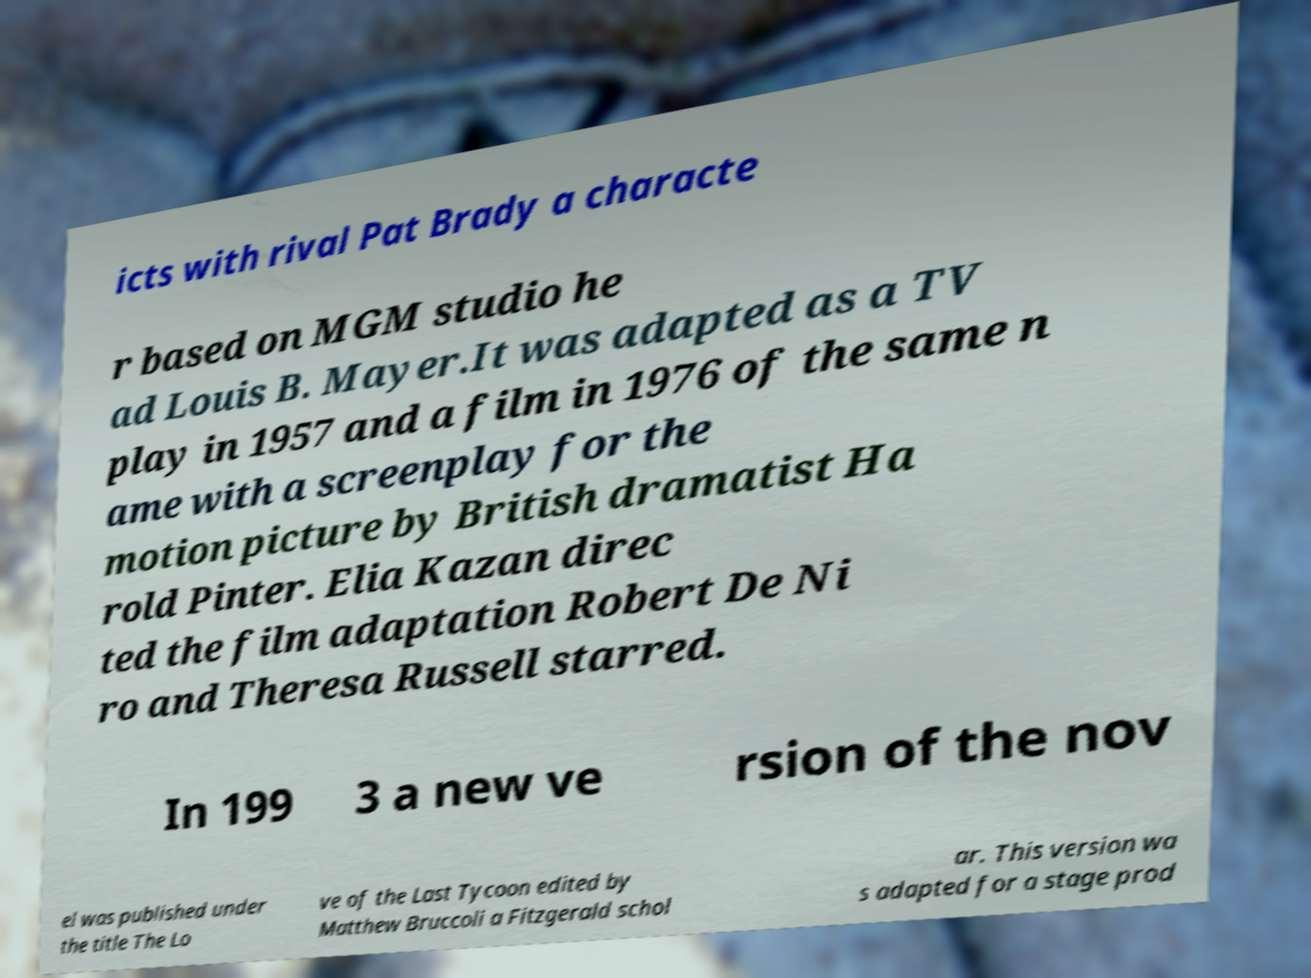Could you extract and type out the text from this image? icts with rival Pat Brady a characte r based on MGM studio he ad Louis B. Mayer.It was adapted as a TV play in 1957 and a film in 1976 of the same n ame with a screenplay for the motion picture by British dramatist Ha rold Pinter. Elia Kazan direc ted the film adaptation Robert De Ni ro and Theresa Russell starred. In 199 3 a new ve rsion of the nov el was published under the title The Lo ve of the Last Tycoon edited by Matthew Bruccoli a Fitzgerald schol ar. This version wa s adapted for a stage prod 